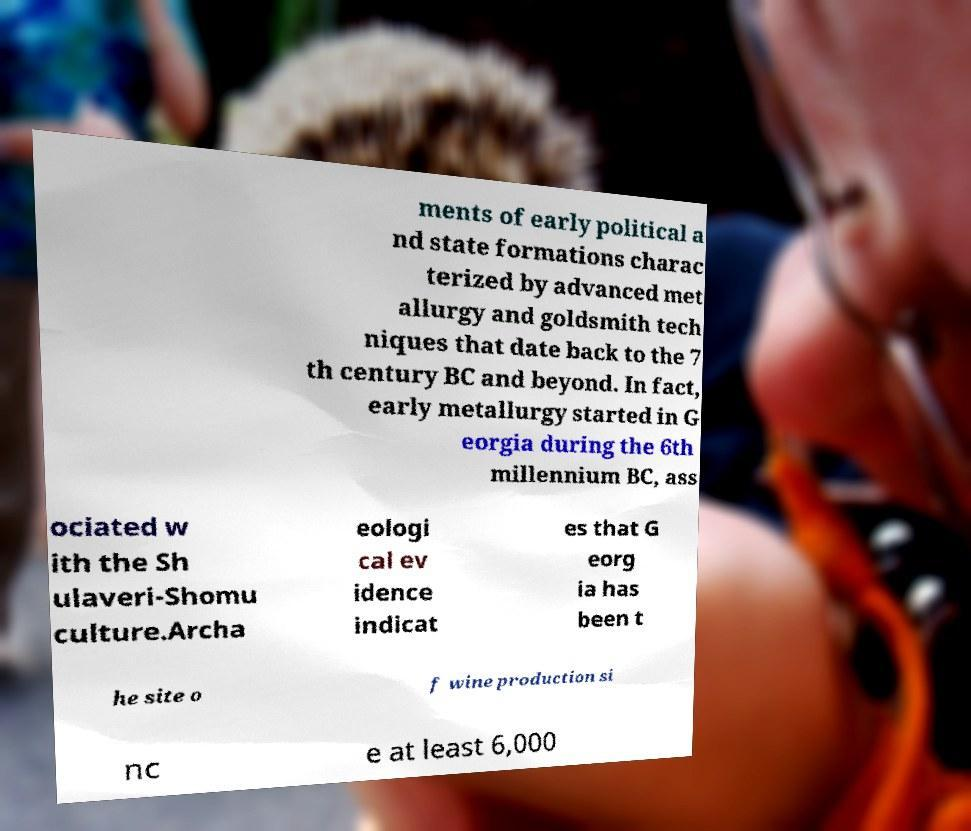Can you read and provide the text displayed in the image?This photo seems to have some interesting text. Can you extract and type it out for me? ments of early political a nd state formations charac terized by advanced met allurgy and goldsmith tech niques that date back to the 7 th century BC and beyond. In fact, early metallurgy started in G eorgia during the 6th millennium BC, ass ociated w ith the Sh ulaveri-Shomu culture.Archa eologi cal ev idence indicat es that G eorg ia has been t he site o f wine production si nc e at least 6,000 